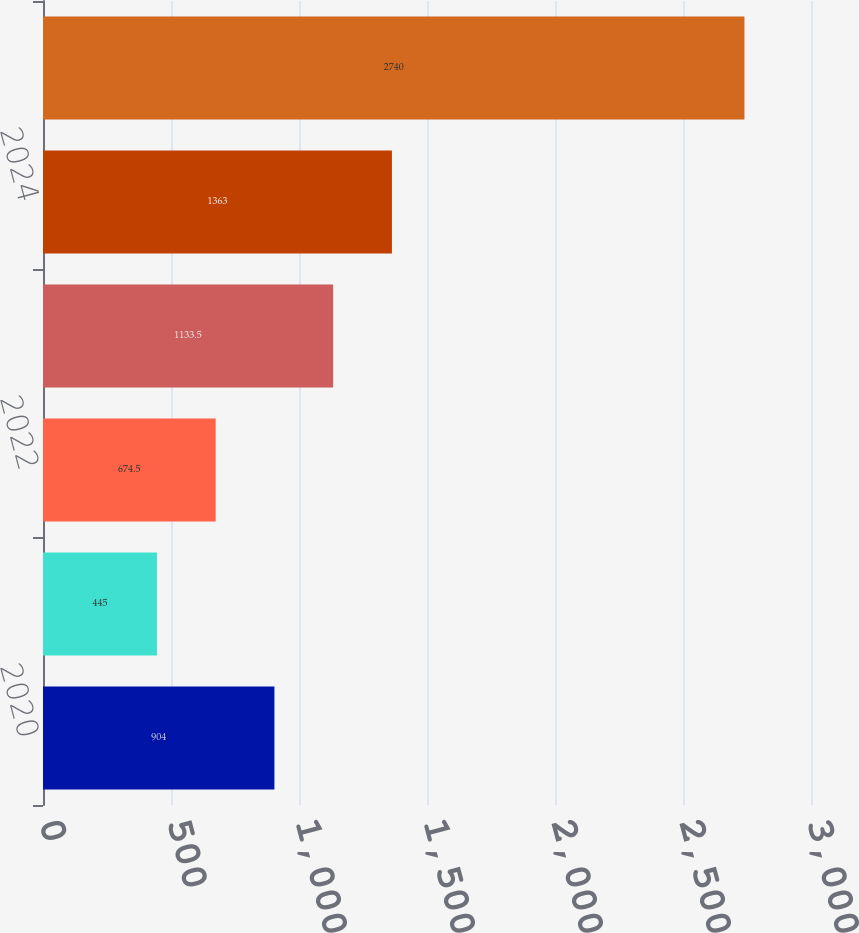Convert chart to OTSL. <chart><loc_0><loc_0><loc_500><loc_500><bar_chart><fcel>2020<fcel>2021<fcel>2022<fcel>2023<fcel>2024<fcel>Next five fiscal years to<nl><fcel>904<fcel>445<fcel>674.5<fcel>1133.5<fcel>1363<fcel>2740<nl></chart> 